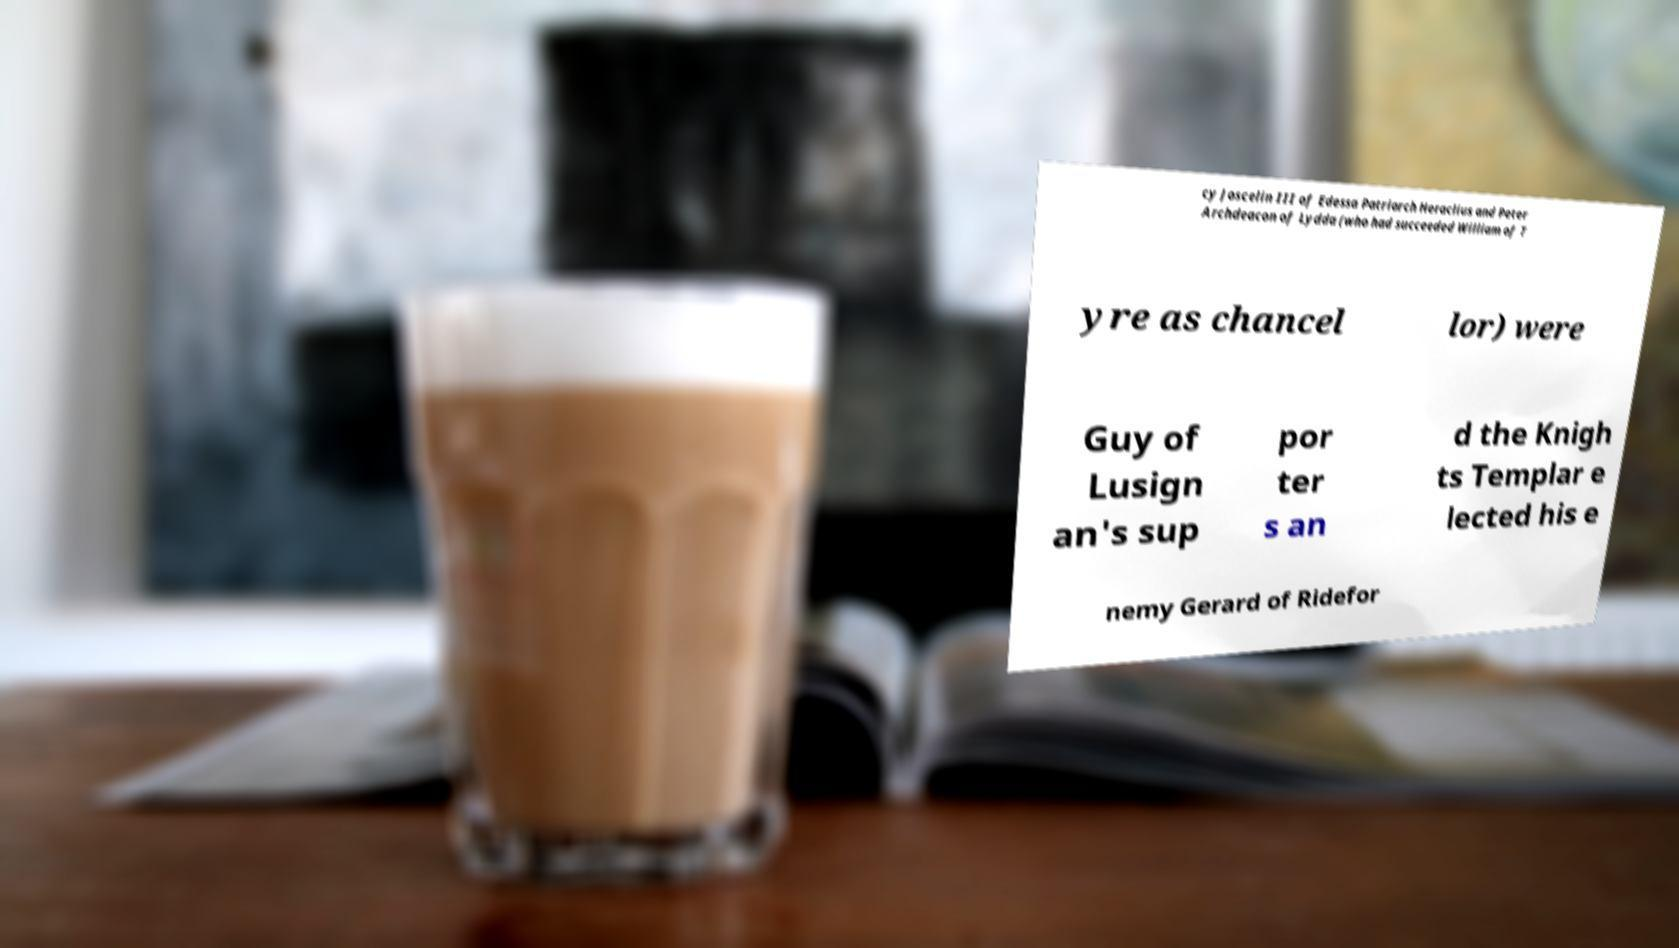Could you extract and type out the text from this image? cy Joscelin III of Edessa Patriarch Heraclius and Peter Archdeacon of Lydda (who had succeeded William of T yre as chancel lor) were Guy of Lusign an's sup por ter s an d the Knigh ts Templar e lected his e nemy Gerard of Ridefor 